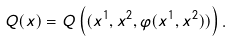Convert formula to latex. <formula><loc_0><loc_0><loc_500><loc_500>Q ( x ) = Q \left ( ( x ^ { 1 } , x ^ { 2 } , \varphi ( x ^ { 1 } , x ^ { 2 } ) ) \right ) .</formula> 